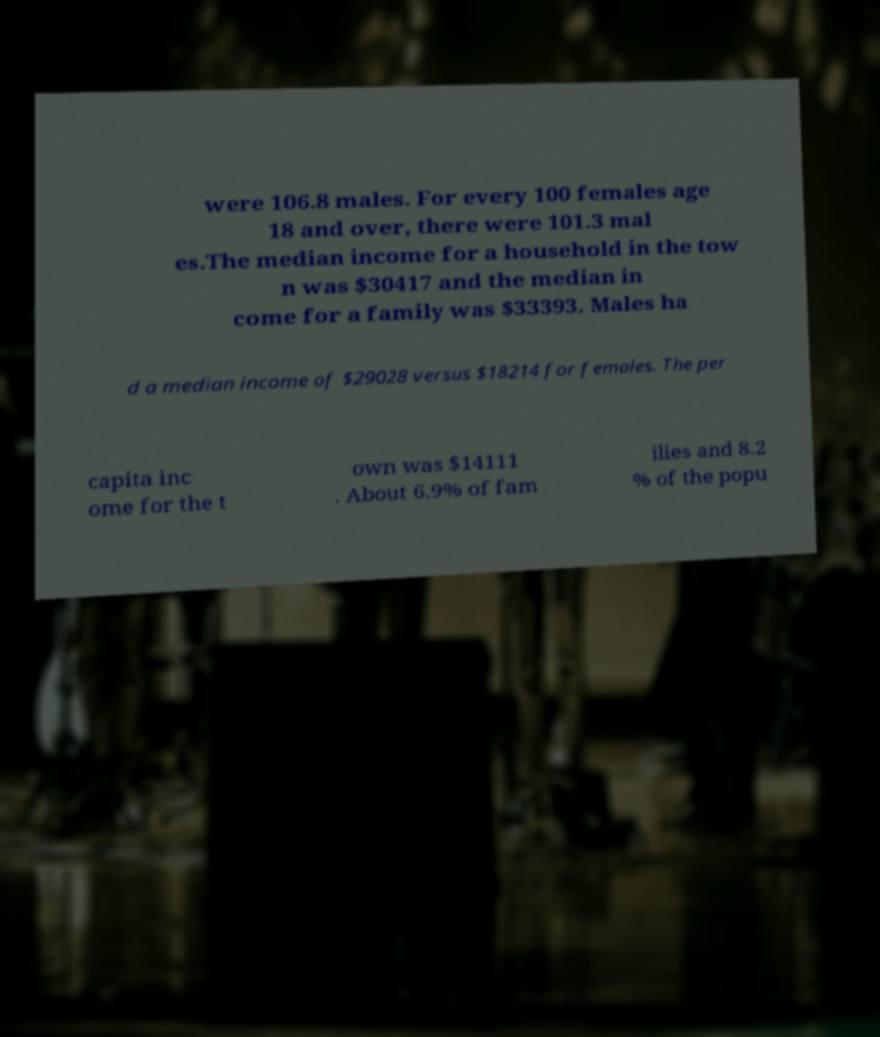There's text embedded in this image that I need extracted. Can you transcribe it verbatim? were 106.8 males. For every 100 females age 18 and over, there were 101.3 mal es.The median income for a household in the tow n was $30417 and the median in come for a family was $33393. Males ha d a median income of $29028 versus $18214 for females. The per capita inc ome for the t own was $14111 . About 6.9% of fam ilies and 8.2 % of the popu 